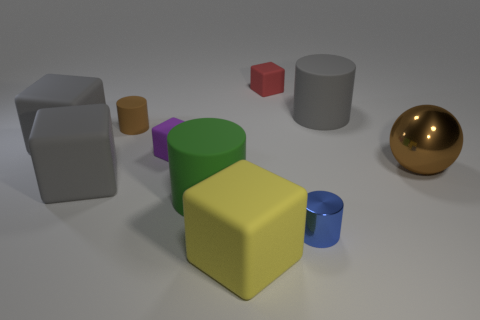Is the small thing that is behind the big gray rubber cylinder made of the same material as the big gray cylinder on the left side of the brown metal sphere?
Your response must be concise. Yes. There is a rubber cylinder that is to the right of the small thing behind the big gray cylinder; what size is it?
Make the answer very short. Large. Are there any big blocks of the same color as the ball?
Keep it short and to the point. No. Is the color of the large matte cube behind the large brown thing the same as the big cylinder behind the tiny purple object?
Offer a terse response. Yes. What is the shape of the blue thing?
Your answer should be compact. Cylinder. There is a tiny red thing; how many cubes are behind it?
Make the answer very short. 0. How many big gray cubes have the same material as the brown ball?
Your answer should be very brief. 0. Do the large cylinder that is on the left side of the gray rubber cylinder and the yellow thing have the same material?
Offer a terse response. Yes. Are any purple rubber blocks visible?
Your answer should be compact. Yes. There is a cylinder that is both in front of the ball and on the left side of the red matte cube; what size is it?
Provide a succinct answer. Large. 